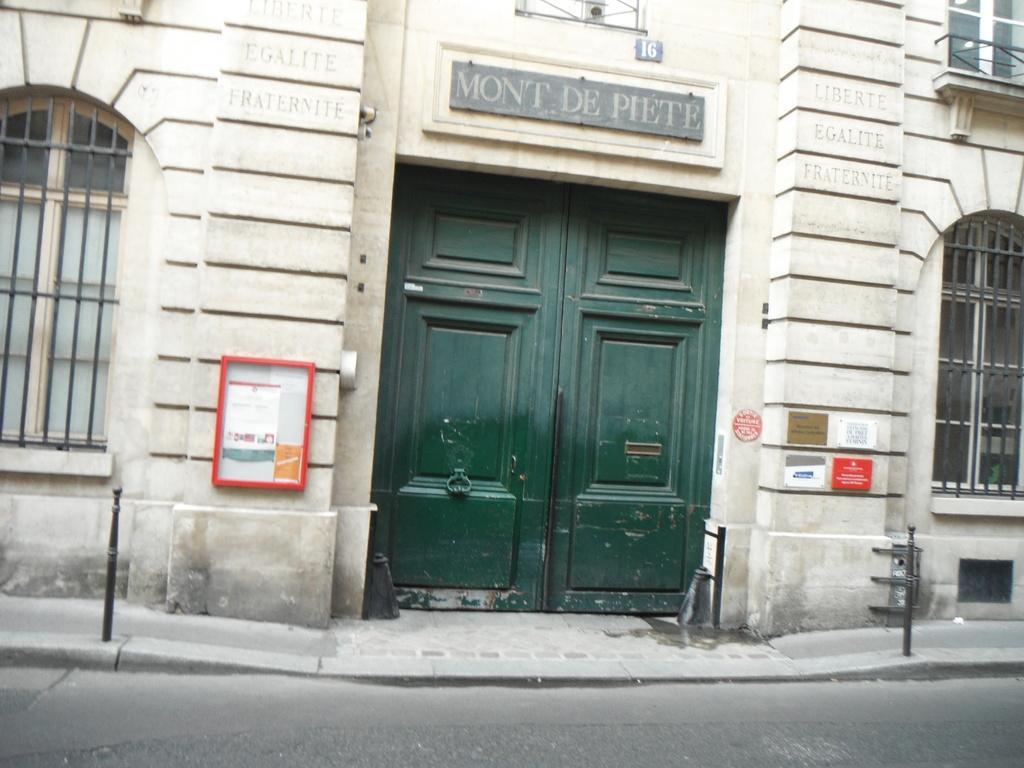How would you summarize this image in a sentence or two? In the image we can see a building, the windows of a building, fence, door, footpath, small pole, board, text and a road. 